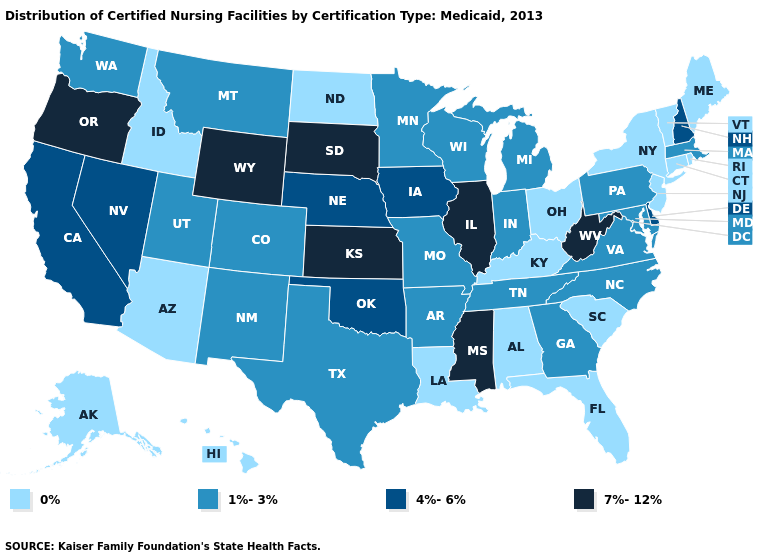Does Washington have a higher value than Kentucky?
Answer briefly. Yes. What is the value of North Carolina?
Be succinct. 1%-3%. Name the states that have a value in the range 0%?
Concise answer only. Alabama, Alaska, Arizona, Connecticut, Florida, Hawaii, Idaho, Kentucky, Louisiana, Maine, New Jersey, New York, North Dakota, Ohio, Rhode Island, South Carolina, Vermont. What is the value of Kentucky?
Be succinct. 0%. Name the states that have a value in the range 0%?
Short answer required. Alabama, Alaska, Arizona, Connecticut, Florida, Hawaii, Idaho, Kentucky, Louisiana, Maine, New Jersey, New York, North Dakota, Ohio, Rhode Island, South Carolina, Vermont. Does Arizona have the highest value in the West?
Write a very short answer. No. Name the states that have a value in the range 4%-6%?
Short answer required. California, Delaware, Iowa, Nebraska, Nevada, New Hampshire, Oklahoma. What is the value of Illinois?
Short answer required. 7%-12%. Among the states that border Minnesota , does South Dakota have the highest value?
Give a very brief answer. Yes. Does Missouri have the lowest value in the MidWest?
Concise answer only. No. How many symbols are there in the legend?
Short answer required. 4. Does Nebraska have a higher value than Vermont?
Keep it brief. Yes. What is the lowest value in the MidWest?
Quick response, please. 0%. Does Rhode Island have the lowest value in the USA?
Be succinct. Yes. Which states have the lowest value in the Northeast?
Concise answer only. Connecticut, Maine, New Jersey, New York, Rhode Island, Vermont. 